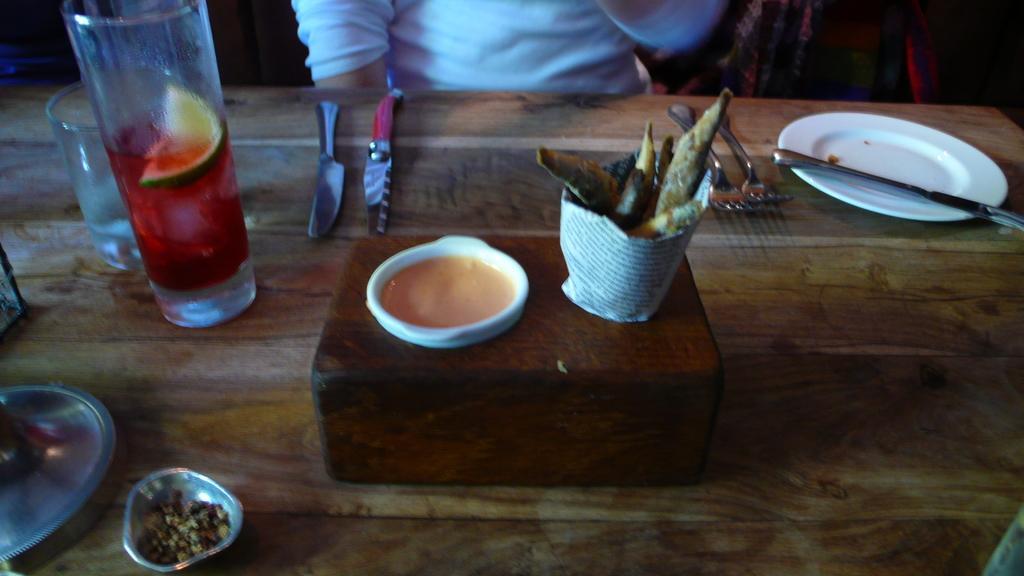Can you describe this image briefly? We can see forks, knives, plate, wooden box, bowls, glasses, utensils and food item on the table. At the top of the image, one person is wearing white color t-shirt. 